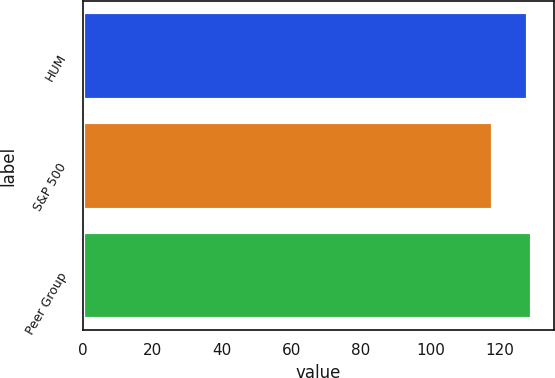Convert chart to OTSL. <chart><loc_0><loc_0><loc_500><loc_500><bar_chart><fcel>HUM<fcel>S&P 500<fcel>Peer Group<nl><fcel>128<fcel>118<fcel>129.1<nl></chart> 